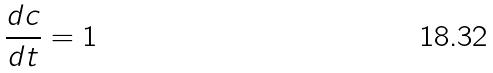Convert formula to latex. <formula><loc_0><loc_0><loc_500><loc_500>\frac { d c } { d t } = 1</formula> 